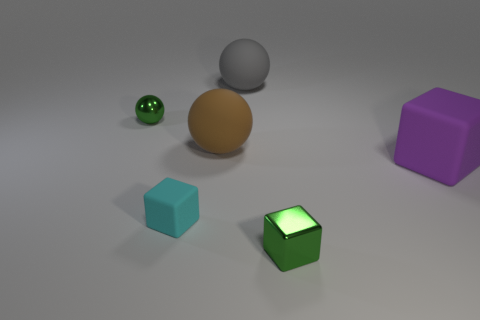Are the big brown ball on the left side of the big gray matte ball and the green object behind the purple matte thing made of the same material?
Ensure brevity in your answer.  No. What number of spheres are either large rubber objects or cyan matte objects?
Offer a very short reply. 2. There is a tiny cube left of the tiny green block that is in front of the big gray ball; what number of cyan matte blocks are in front of it?
Keep it short and to the point. 0. There is a brown thing that is the same shape as the gray thing; what material is it?
Make the answer very short. Rubber. Are there any other things that are made of the same material as the large purple object?
Provide a succinct answer. Yes. There is a rubber thing that is behind the small green shiny ball; what color is it?
Provide a succinct answer. Gray. Is the cyan object made of the same material as the small green object that is in front of the small cyan object?
Your response must be concise. No. What is the big brown ball made of?
Provide a succinct answer. Rubber. There is a big purple thing that is the same material as the gray sphere; what is its shape?
Keep it short and to the point. Cube. What number of other things are the same shape as the purple thing?
Provide a succinct answer. 2. 